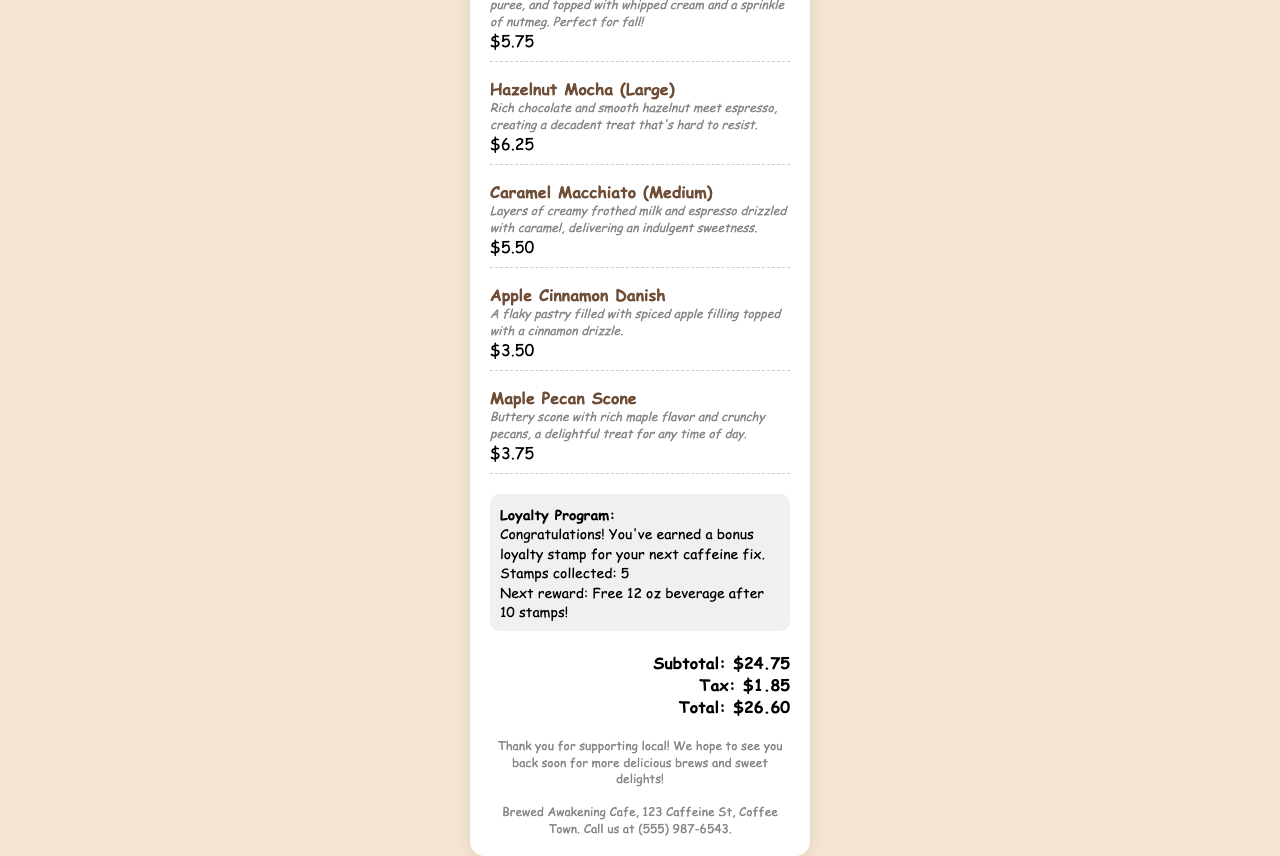What is the cafe's name? The name of the cafe is prominently displayed at the top of the receipt.
Answer: Brewed Awakening Cafe What date and time is on the receipt? The receipt contains the date and time of the purchase in the header section.
Answer: 2023-10-15 10:35 AM How much is the Pumpkin Spice Latte? The price of the Pumpkin Spice Latte is listed under the item description.
Answer: $5.75 How many stamps do you have in the loyalty program? The loyalty section indicates the number of collected stamps.
Answer: 5 What is the total amount charged? The total amount is calculated in the total section of the receipt.
Answer: $26.60 What is the next reward after collecting 10 stamps? The loyalty section states the reward for collecting 10 stamps.
Answer: Free 12 oz beverage What item contains rich chocolate and hazelnut? The description mentions the items by their ingredients.
Answer: Hazelnut Mocha Which pastry is filled with spiced apple filling? The item description highlights what the specific pastry contains.
Answer: Apple Cinnamon Danish What is the subtotal before tax? The subtotal is listed directly in the total section of the receipt.
Answer: $24.75 